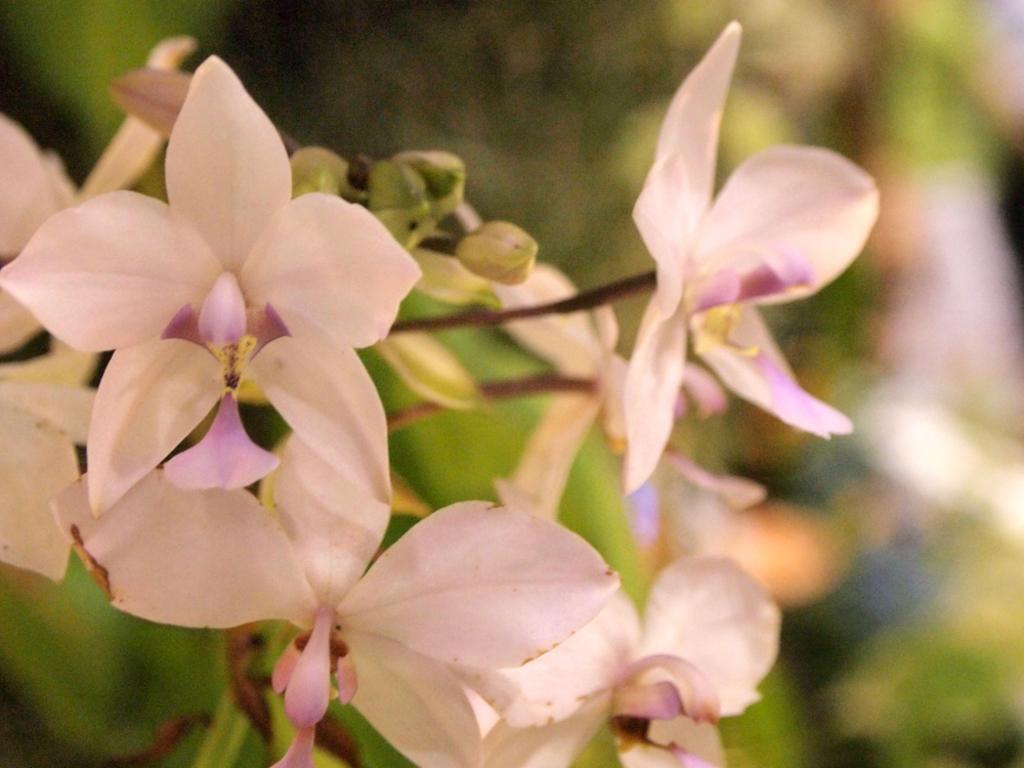Could you give a brief overview of what you see in this image? In this image I can see few white and purple color flowers. I can see green color and blurred background. 